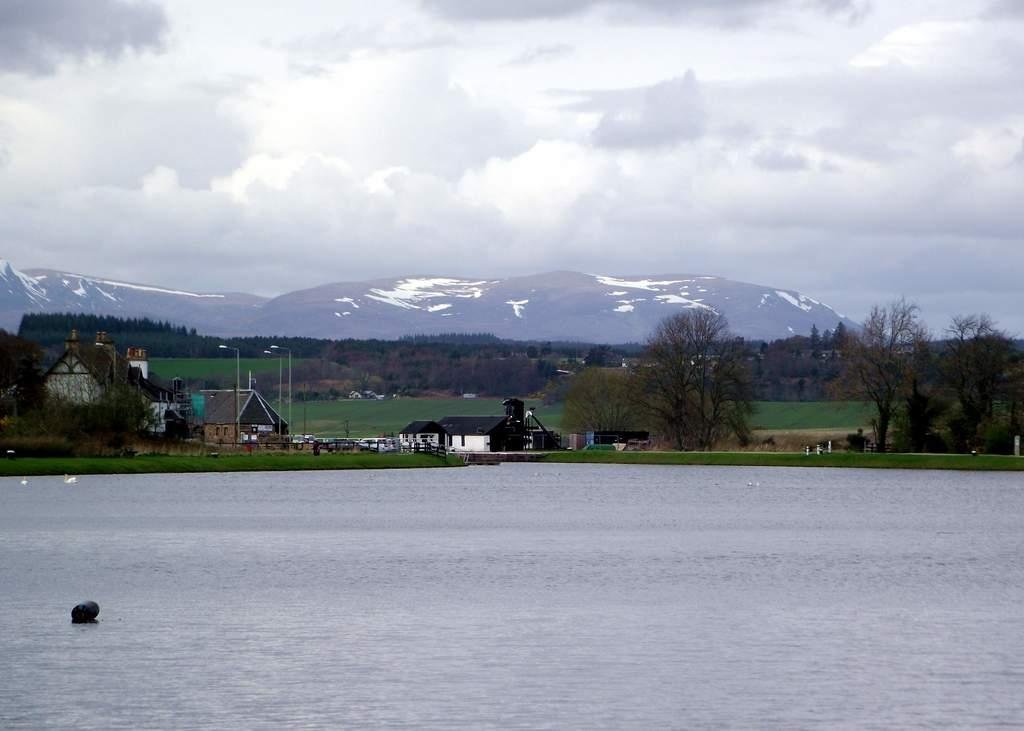What type of structures can be seen in the image? There are houses in the image. What are the light poles used for in the image? The light poles provide illumination in the image. What type of vegetation is present in the image? There are trees in the image. What natural feature can be seen in the image? There is water visible in the image. What geographical feature is present in the image? There are mountains in the image. What animals can be seen on the water in the image? There are two white birds on the water in the image. What is the color of the sky in the image? The sky appears to be white in color. Where is the cub playing in the image? There is no cub present in the image. What type of farming equipment can be seen in the image? There is no farming equipment, such as a plough, present in the image. Who is wearing the crown in the image? There is no person wearing a crown in the image. 